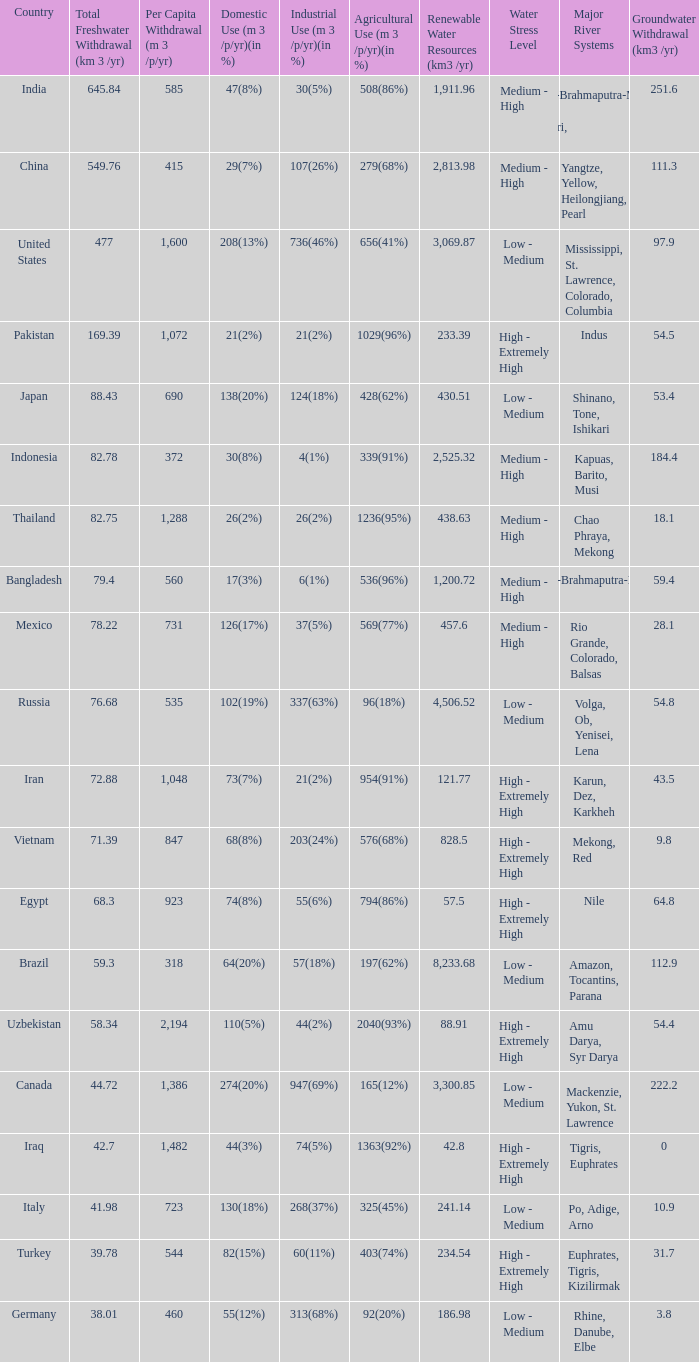What is the highest Per Capita Withdrawal (m 3 /p/yr), when Agricultural Use (m 3 /p/yr)(in %) is 1363(92%), and when Total Freshwater Withdrawal (km 3 /yr) is less than 42.7? None. 